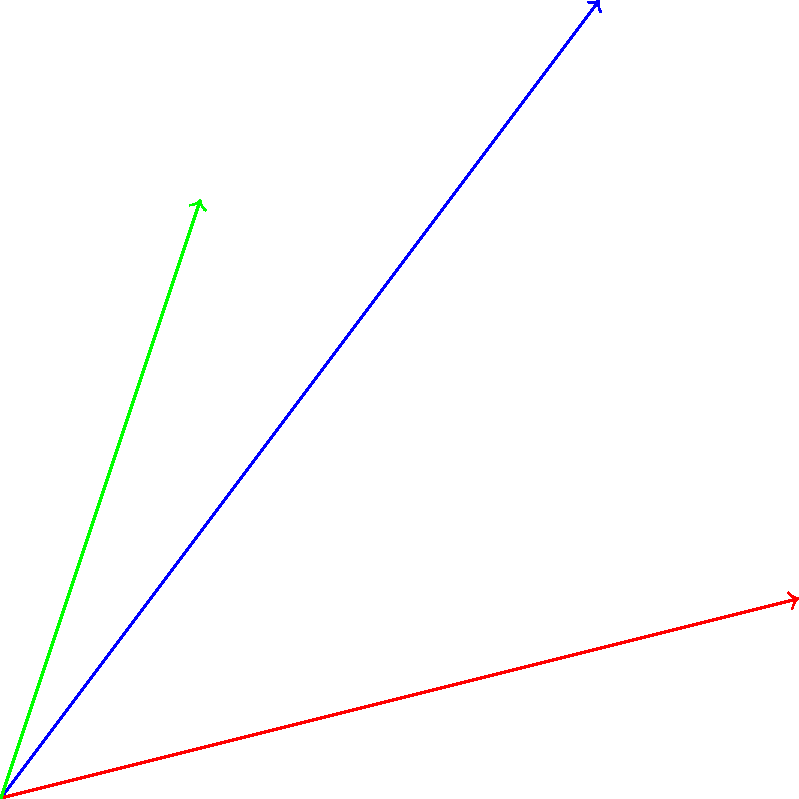Three force vectors $\vec{F_1}$, $\vec{F_2}$, and $\vec{F_3}$ are acting on a point as shown in the diagram. $\vec{F_1} = 5\hat{i} + 4\hat{j}$, $\vec{F_2} = 4\hat{i} + \hat{j}$, and $\vec{F_3} = \hat{i} + 3\hat{j}$. Calculate the magnitude of the resultant force vector $\vec{R}$. To find the magnitude of the resultant force vector, we'll follow these steps:

1) First, we need to add all the force vectors:
   $\vec{R} = \vec{F_1} + \vec{F_2} + \vec{F_3}$

2) Let's add the i-components and j-components separately:
   i-component: $(5 + 4 + 1)\hat{i} = 10\hat{i}$
   j-component: $(4 + 1 + 3)\hat{j} = 8\hat{j}$

3) So, the resultant vector is:
   $\vec{R} = 10\hat{i} + 8\hat{j}$

4) To find the magnitude of $\vec{R}$, we use the Pythagorean theorem:
   $|\vec{R}| = \sqrt{(10)^2 + (8)^2}$

5) Simplify:
   $|\vec{R}| = \sqrt{100 + 64} = \sqrt{164}$

6) Simplify the square root:
   $|\vec{R}| = 2\sqrt{41}$

Therefore, the magnitude of the resultant force vector is $2\sqrt{41}$ units.
Answer: $2\sqrt{41}$ units 